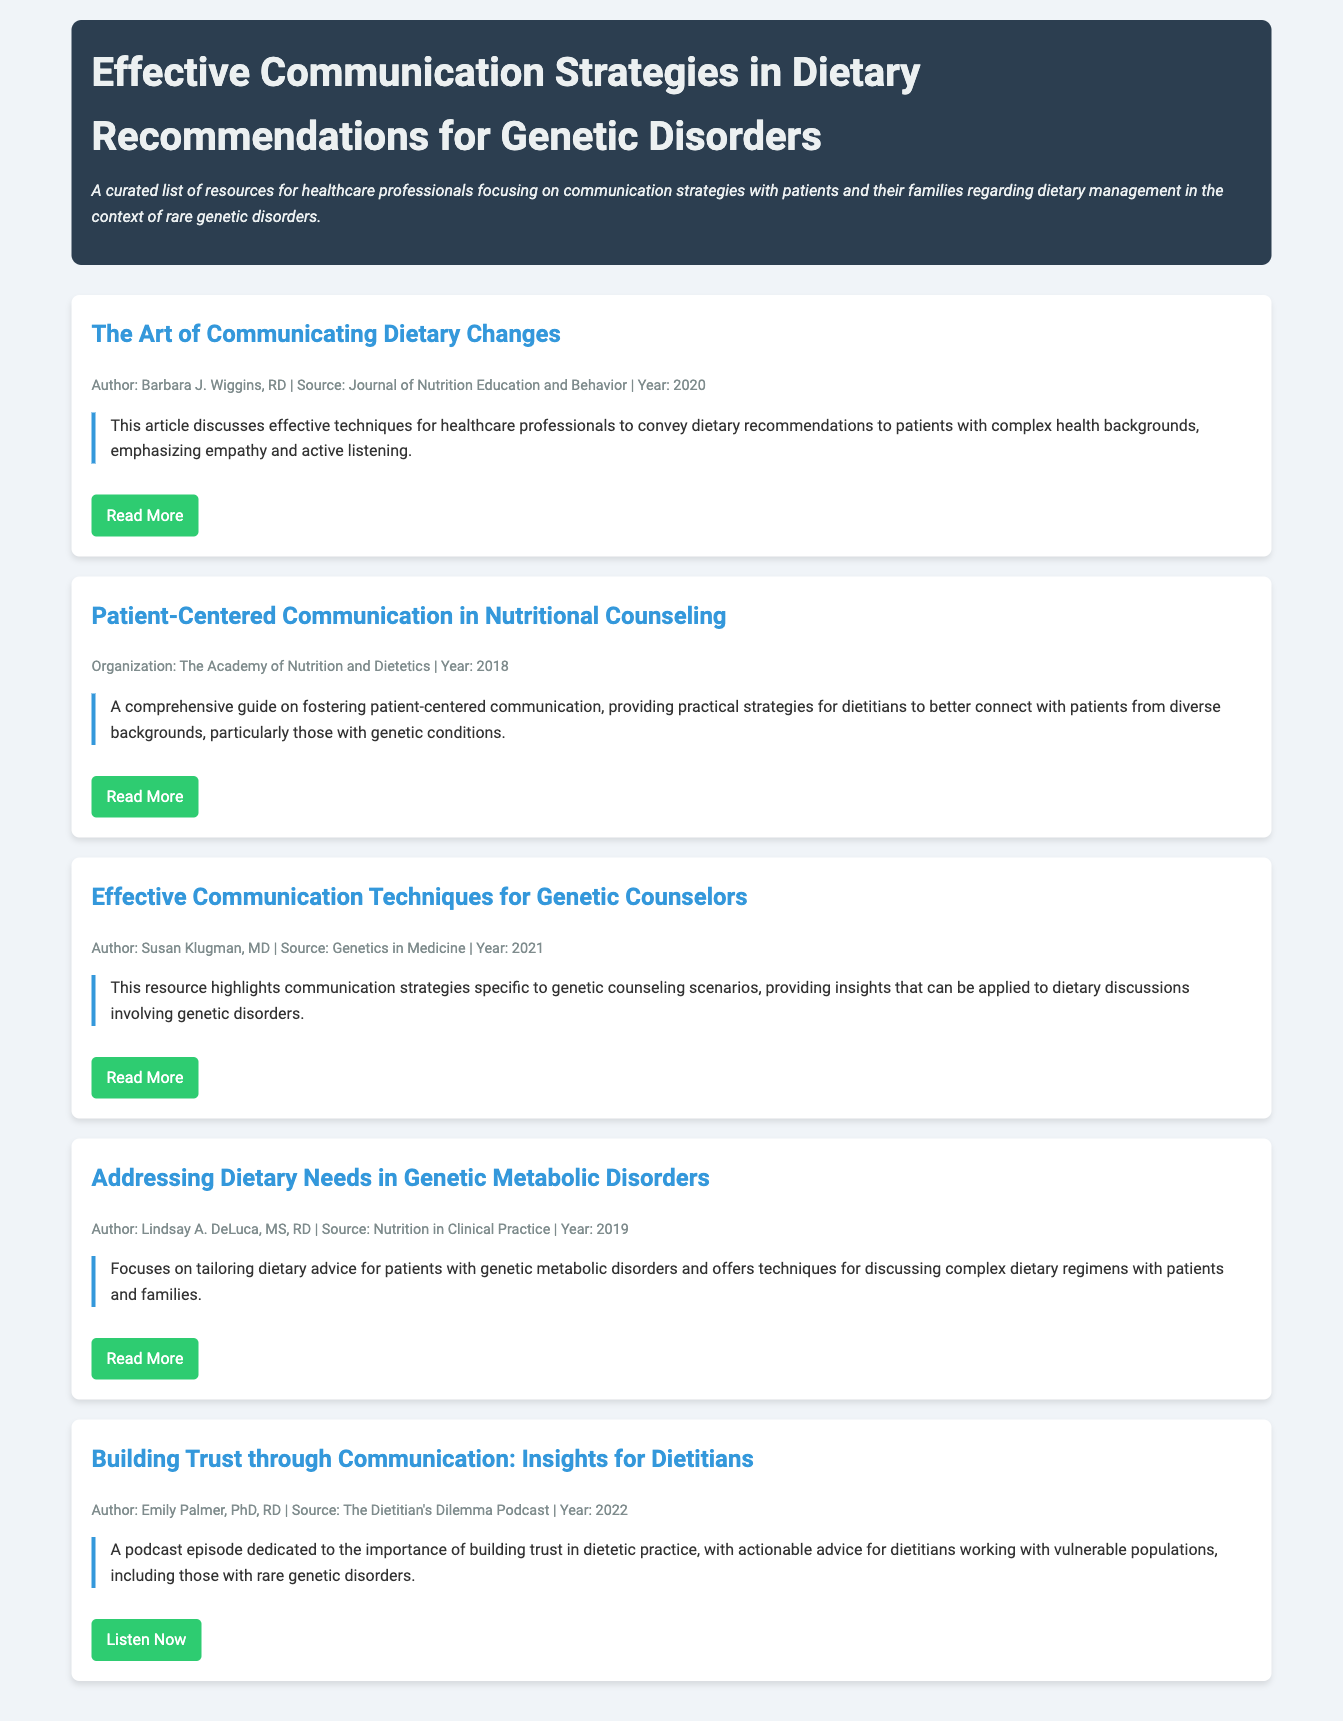What is the title of the document? The title of the document is prominently displayed at the top of the page.
Answer: Effective Communication Strategies in Dietary Recommendations for Genetic Disorders Who is the author of "The Art of Communicating Dietary Changes"? The author's name is listed in the resource section under the title and meta information.
Answer: Barbara J. Wiggins, RD In what year was "Patient-Centered Communication in Nutritional Counseling" published? The publication year is mentioned in the meta section of the resource.
Answer: 2018 What type of resource is "Building Trust through Communication: Insights for Dietitians"? The resource type can be inferred from its format and content provided in the document.
Answer: Podcast Which organization published the resource on patient-centered communication? The organization is specified next to the author's name in the resource's metadata.
Answer: The Academy of Nutrition and Dietetics What is a main focus of "Addressing Dietary Needs in Genetic Metabolic Disorders"? The summary provides an overview of the main focus of the resource.
Answer: Tailoring dietary advice What is one effective technique discussed in the document for communicating dietary recommendations? Effective communication techniques are discussed throughout the document, indicating various methods.
Answer: Empathy and active listening Who authored "Effective Communication Techniques for Genetic Counselors"? It is common practice to list the author with the publication's details in the resource section.
Answer: Susan Klugman, MD 